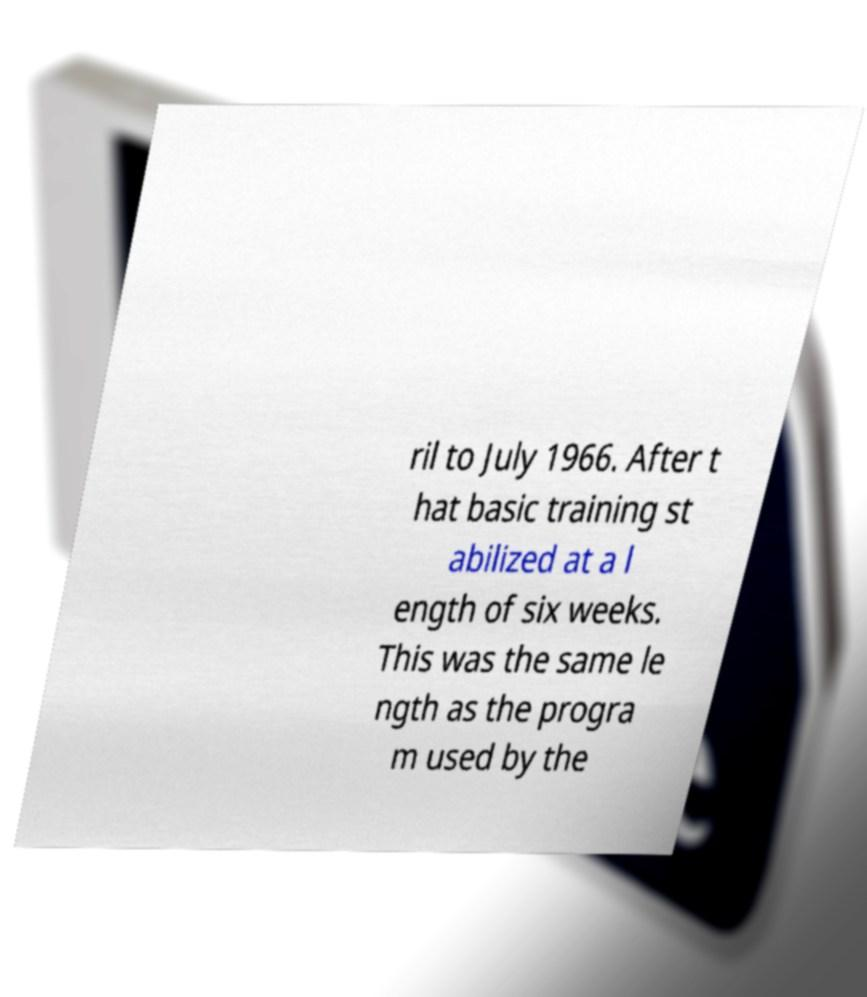Could you assist in decoding the text presented in this image and type it out clearly? ril to July 1966. After t hat basic training st abilized at a l ength of six weeks. This was the same le ngth as the progra m used by the 